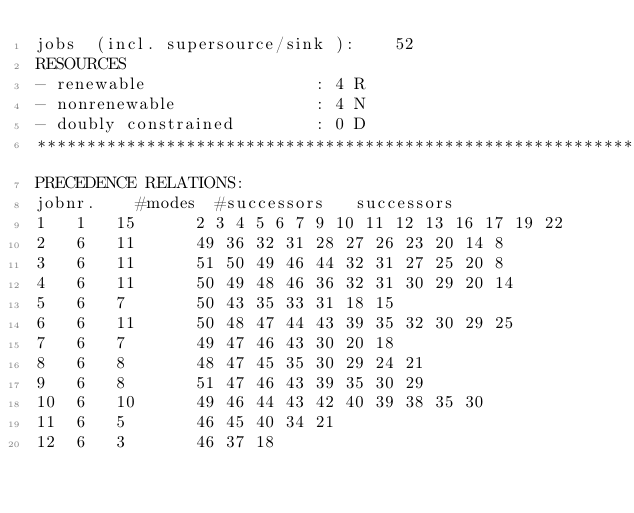Convert code to text. <code><loc_0><loc_0><loc_500><loc_500><_ObjectiveC_>jobs  (incl. supersource/sink ):	52
RESOURCES
- renewable                 : 4 R
- nonrenewable              : 4 N
- doubly constrained        : 0 D
************************************************************************
PRECEDENCE RELATIONS:
jobnr.    #modes  #successors   successors
1	1	15		2 3 4 5 6 7 9 10 11 12 13 16 17 19 22 
2	6	11		49 36 32 31 28 27 26 23 20 14 8 
3	6	11		51 50 49 46 44 32 31 27 25 20 8 
4	6	11		50 49 48 46 36 32 31 30 29 20 14 
5	6	7		50 43 35 33 31 18 15 
6	6	11		50 48 47 44 43 39 35 32 30 29 25 
7	6	7		49 47 46 43 30 20 18 
8	6	8		48 47 45 35 30 29 24 21 
9	6	8		51 47 46 43 39 35 30 29 
10	6	10		49 46 44 43 42 40 39 38 35 30 
11	6	5		46 45 40 34 21 
12	6	3		46 37 18 </code> 